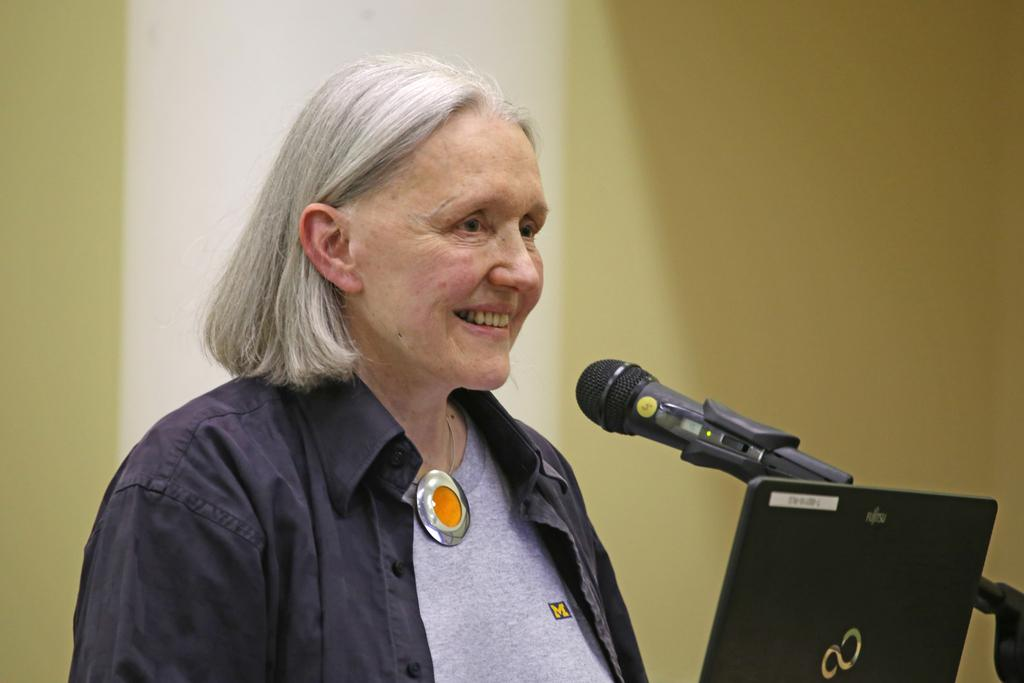Who is present in the image? There is a woman in the image. What is the woman doing in the image? The woman is standing and smiling. What is the woman wearing in the image? The woman is wearing a jacket. What objects can be seen in the image besides the woman? There is a microphone and a black color laptop in the image. How would you describe the background of the image? The background of the image is blurred. What type of ball is the woman holding in the image? There is no ball present in the image. What story is the woman telling using the pen in the image? There is no pen or storytelling depicted in the image. 